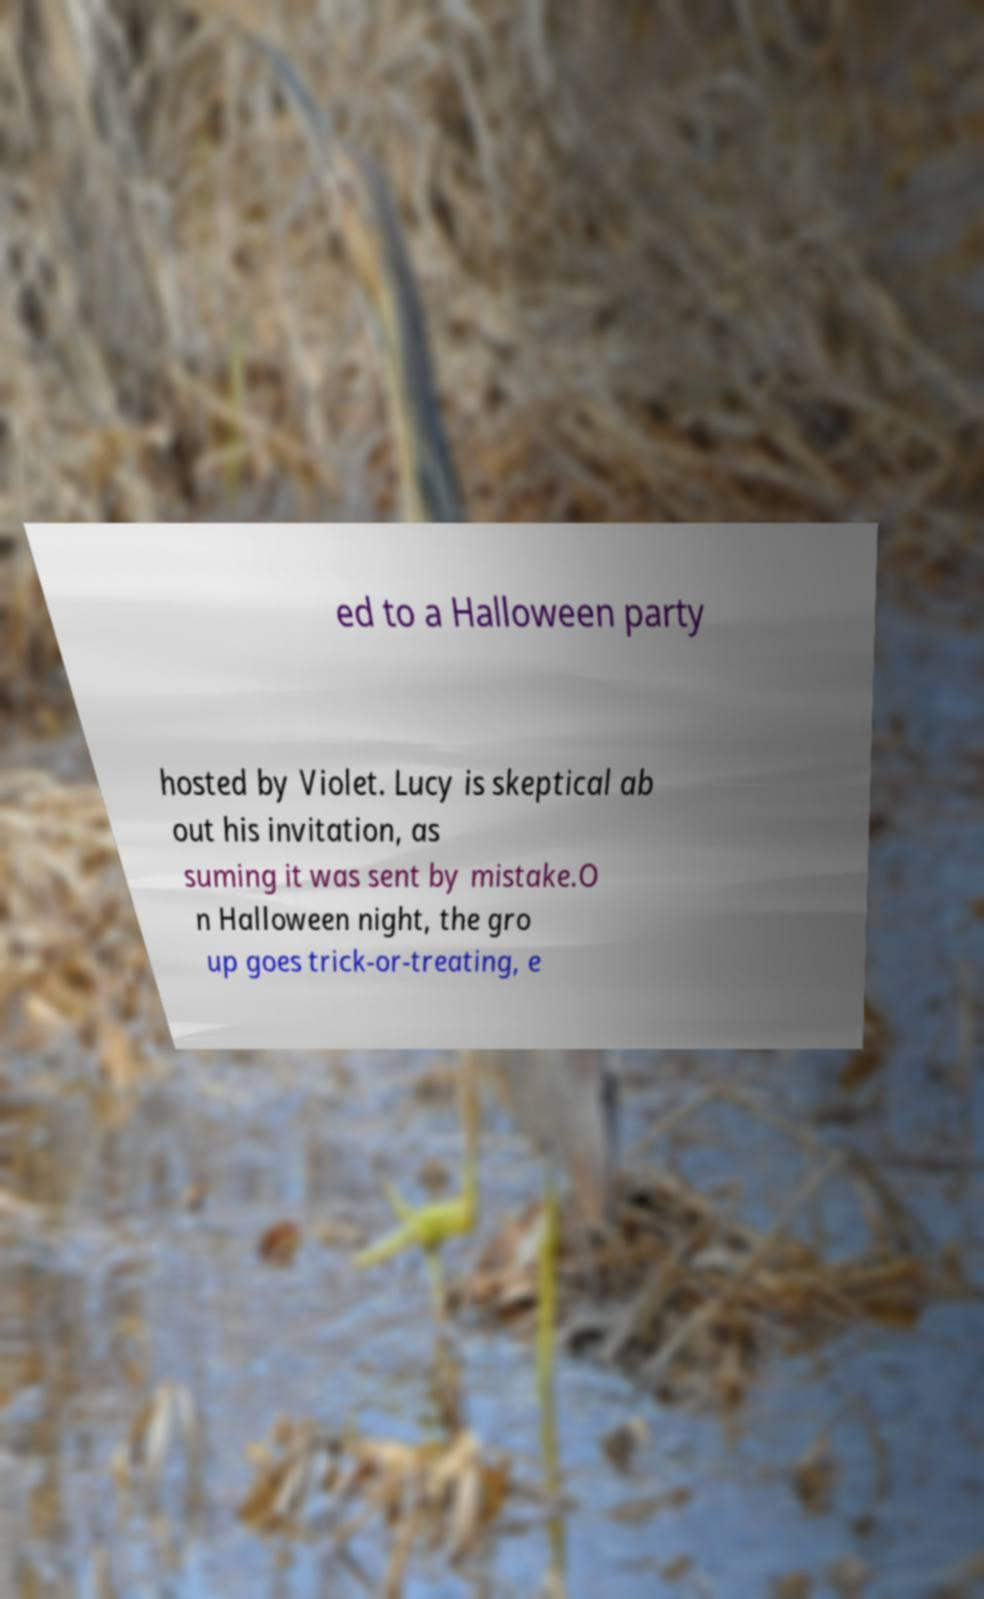I need the written content from this picture converted into text. Can you do that? ed to a Halloween party hosted by Violet. Lucy is skeptical ab out his invitation, as suming it was sent by mistake.O n Halloween night, the gro up goes trick-or-treating, e 